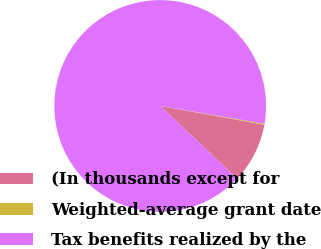Convert chart to OTSL. <chart><loc_0><loc_0><loc_500><loc_500><pie_chart><fcel>(In thousands except for<fcel>Weighted-average grant date<fcel>Tax benefits realized by the<nl><fcel>9.2%<fcel>0.15%<fcel>90.65%<nl></chart> 